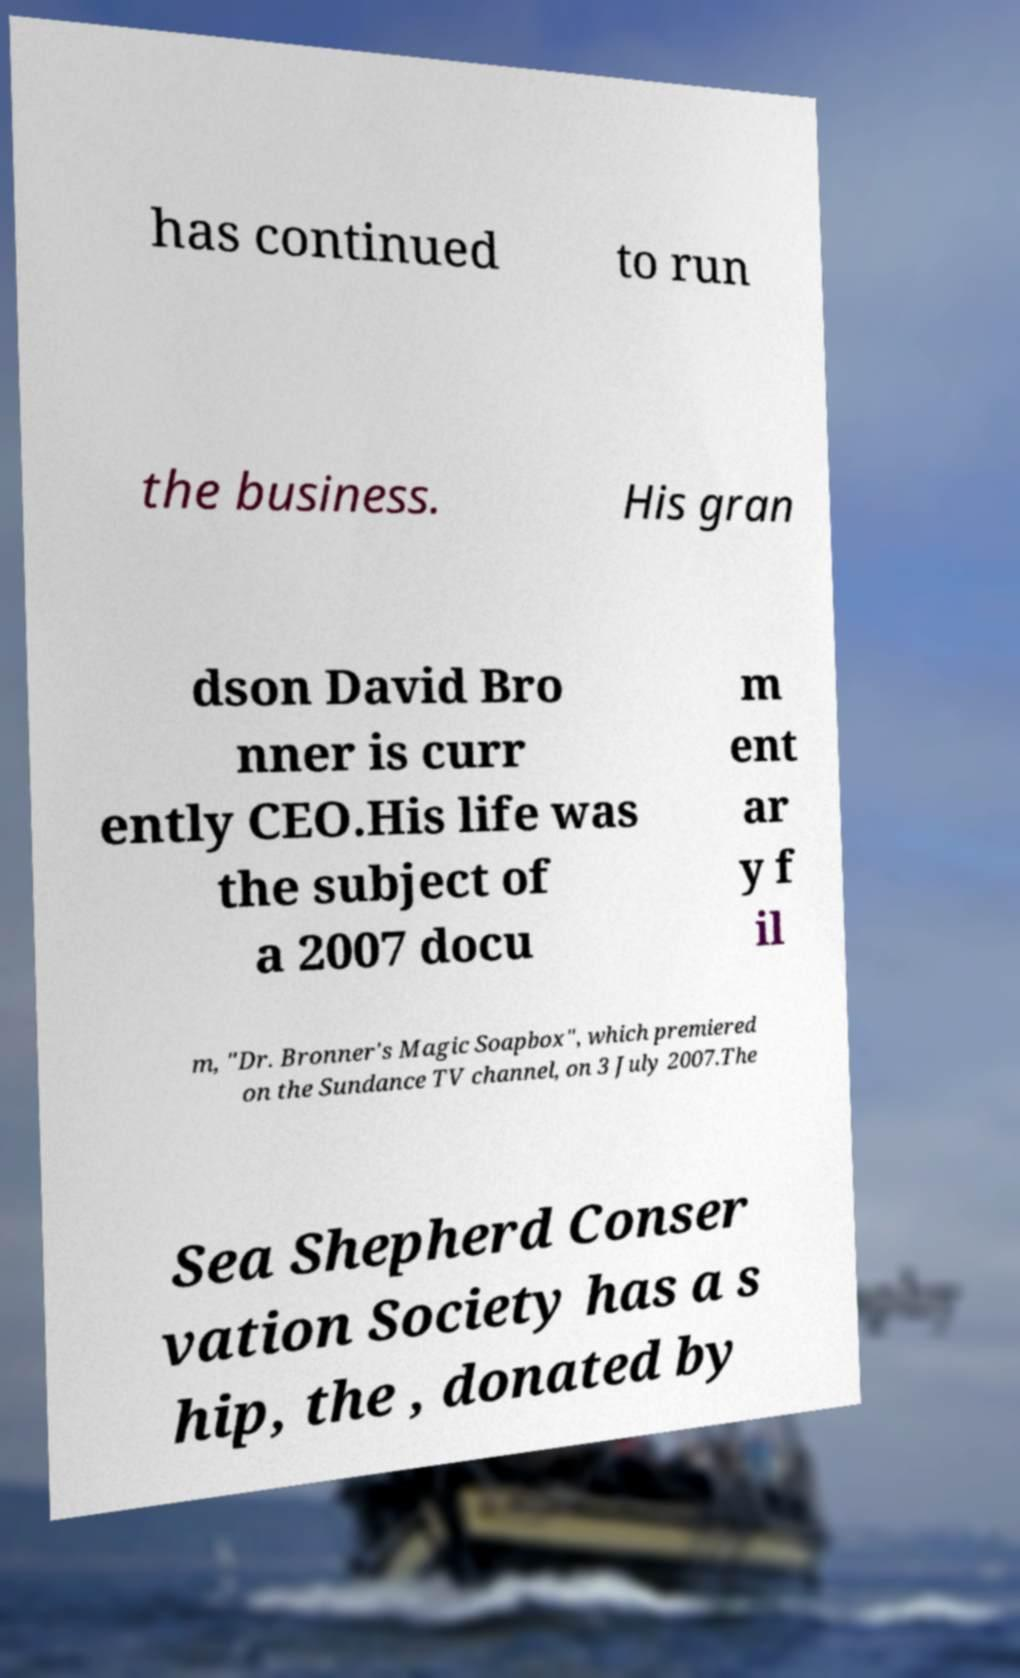There's text embedded in this image that I need extracted. Can you transcribe it verbatim? has continued to run the business. His gran dson David Bro nner is curr ently CEO.His life was the subject of a 2007 docu m ent ar y f il m, "Dr. Bronner's Magic Soapbox", which premiered on the Sundance TV channel, on 3 July 2007.The Sea Shepherd Conser vation Society has a s hip, the , donated by 